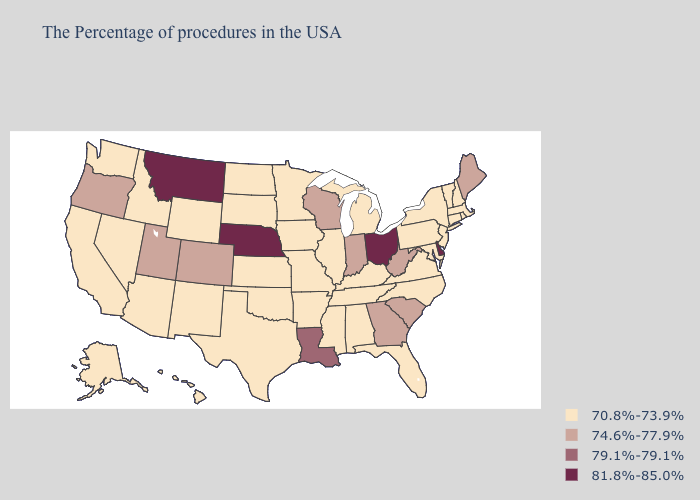Among the states that border Washington , does Idaho have the lowest value?
Quick response, please. Yes. What is the lowest value in states that border Kentucky?
Answer briefly. 70.8%-73.9%. What is the value of Florida?
Give a very brief answer. 70.8%-73.9%. What is the highest value in states that border Kentucky?
Short answer required. 81.8%-85.0%. Does the first symbol in the legend represent the smallest category?
Keep it brief. Yes. Does New Mexico have a higher value than Hawaii?
Concise answer only. No. Among the states that border Colorado , does Nebraska have the lowest value?
Give a very brief answer. No. Name the states that have a value in the range 81.8%-85.0%?
Write a very short answer. Delaware, Ohio, Nebraska, Montana. What is the value of Colorado?
Short answer required. 74.6%-77.9%. What is the highest value in states that border Rhode Island?
Answer briefly. 70.8%-73.9%. Does Arizona have a higher value than Michigan?
Answer briefly. No. Among the states that border North Carolina , which have the highest value?
Write a very short answer. South Carolina, Georgia. What is the lowest value in the USA?
Concise answer only. 70.8%-73.9%. What is the value of Vermont?
Keep it brief. 70.8%-73.9%. 